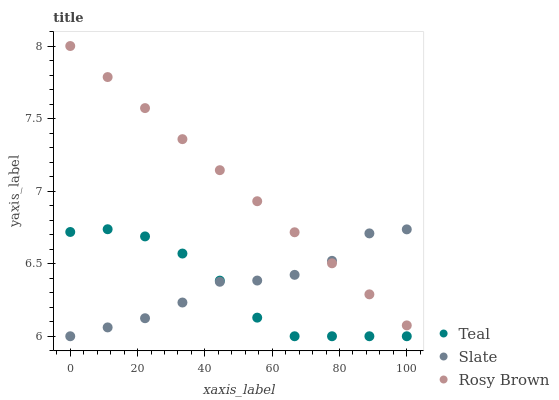Does Teal have the minimum area under the curve?
Answer yes or no. Yes. Does Rosy Brown have the maximum area under the curve?
Answer yes or no. Yes. Does Rosy Brown have the minimum area under the curve?
Answer yes or no. No. Does Teal have the maximum area under the curve?
Answer yes or no. No. Is Rosy Brown the smoothest?
Answer yes or no. Yes. Is Slate the roughest?
Answer yes or no. Yes. Is Teal the smoothest?
Answer yes or no. No. Is Teal the roughest?
Answer yes or no. No. Does Slate have the lowest value?
Answer yes or no. Yes. Does Rosy Brown have the lowest value?
Answer yes or no. No. Does Rosy Brown have the highest value?
Answer yes or no. Yes. Does Teal have the highest value?
Answer yes or no. No. Is Teal less than Rosy Brown?
Answer yes or no. Yes. Is Rosy Brown greater than Teal?
Answer yes or no. Yes. Does Slate intersect Teal?
Answer yes or no. Yes. Is Slate less than Teal?
Answer yes or no. No. Is Slate greater than Teal?
Answer yes or no. No. Does Teal intersect Rosy Brown?
Answer yes or no. No. 